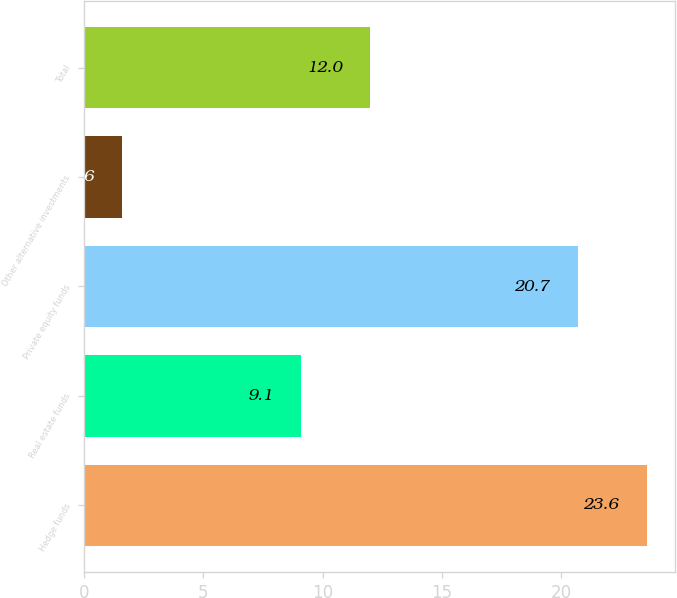Convert chart. <chart><loc_0><loc_0><loc_500><loc_500><bar_chart><fcel>Hedge funds<fcel>Real estate funds<fcel>Private equity funds<fcel>Other alternative investments<fcel>Total<nl><fcel>23.6<fcel>9.1<fcel>20.7<fcel>1.6<fcel>12<nl></chart> 